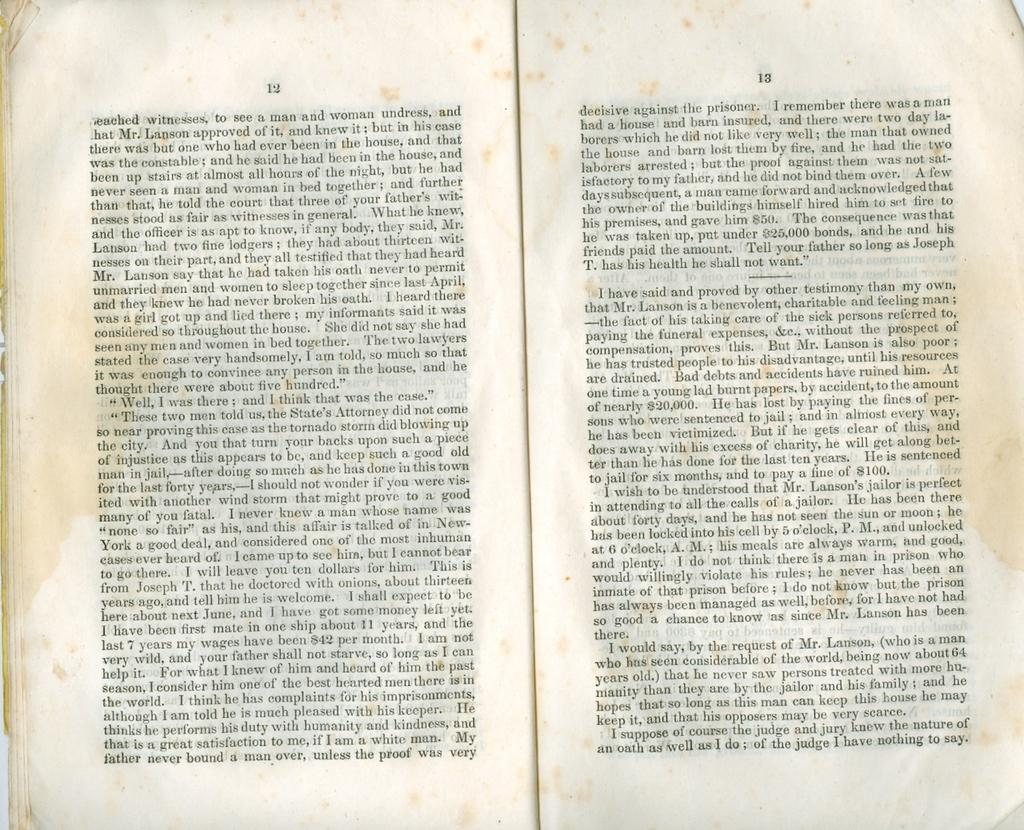<image>
Share a concise interpretation of the image provided. Two pages of a book that feature characters such as Mr. Lanson 